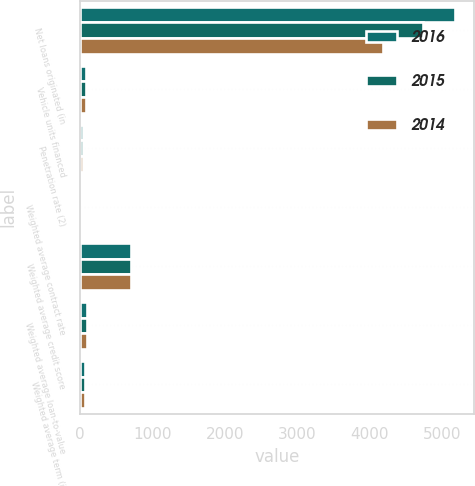Convert chart to OTSL. <chart><loc_0><loc_0><loc_500><loc_500><stacked_bar_chart><ecel><fcel>Net loans originated (in<fcel>Vehicle units financed<fcel>Penetration rate (2)<fcel>Weighted average contract rate<fcel>Weighted average credit score<fcel>Weighted average loan-to-value<fcel>Weighted average term (in<nl><fcel>2016<fcel>5171<fcel>79.8<fcel>42.8<fcel>7.3<fcel>702<fcel>94.6<fcel>65.9<nl><fcel>2015<fcel>4727.8<fcel>79.8<fcel>41.8<fcel>7.1<fcel>701<fcel>94.2<fcel>65.4<nl><fcel>2014<fcel>4183.9<fcel>79.8<fcel>41.5<fcel>7<fcel>702<fcel>93.7<fcel>65.4<nl></chart> 